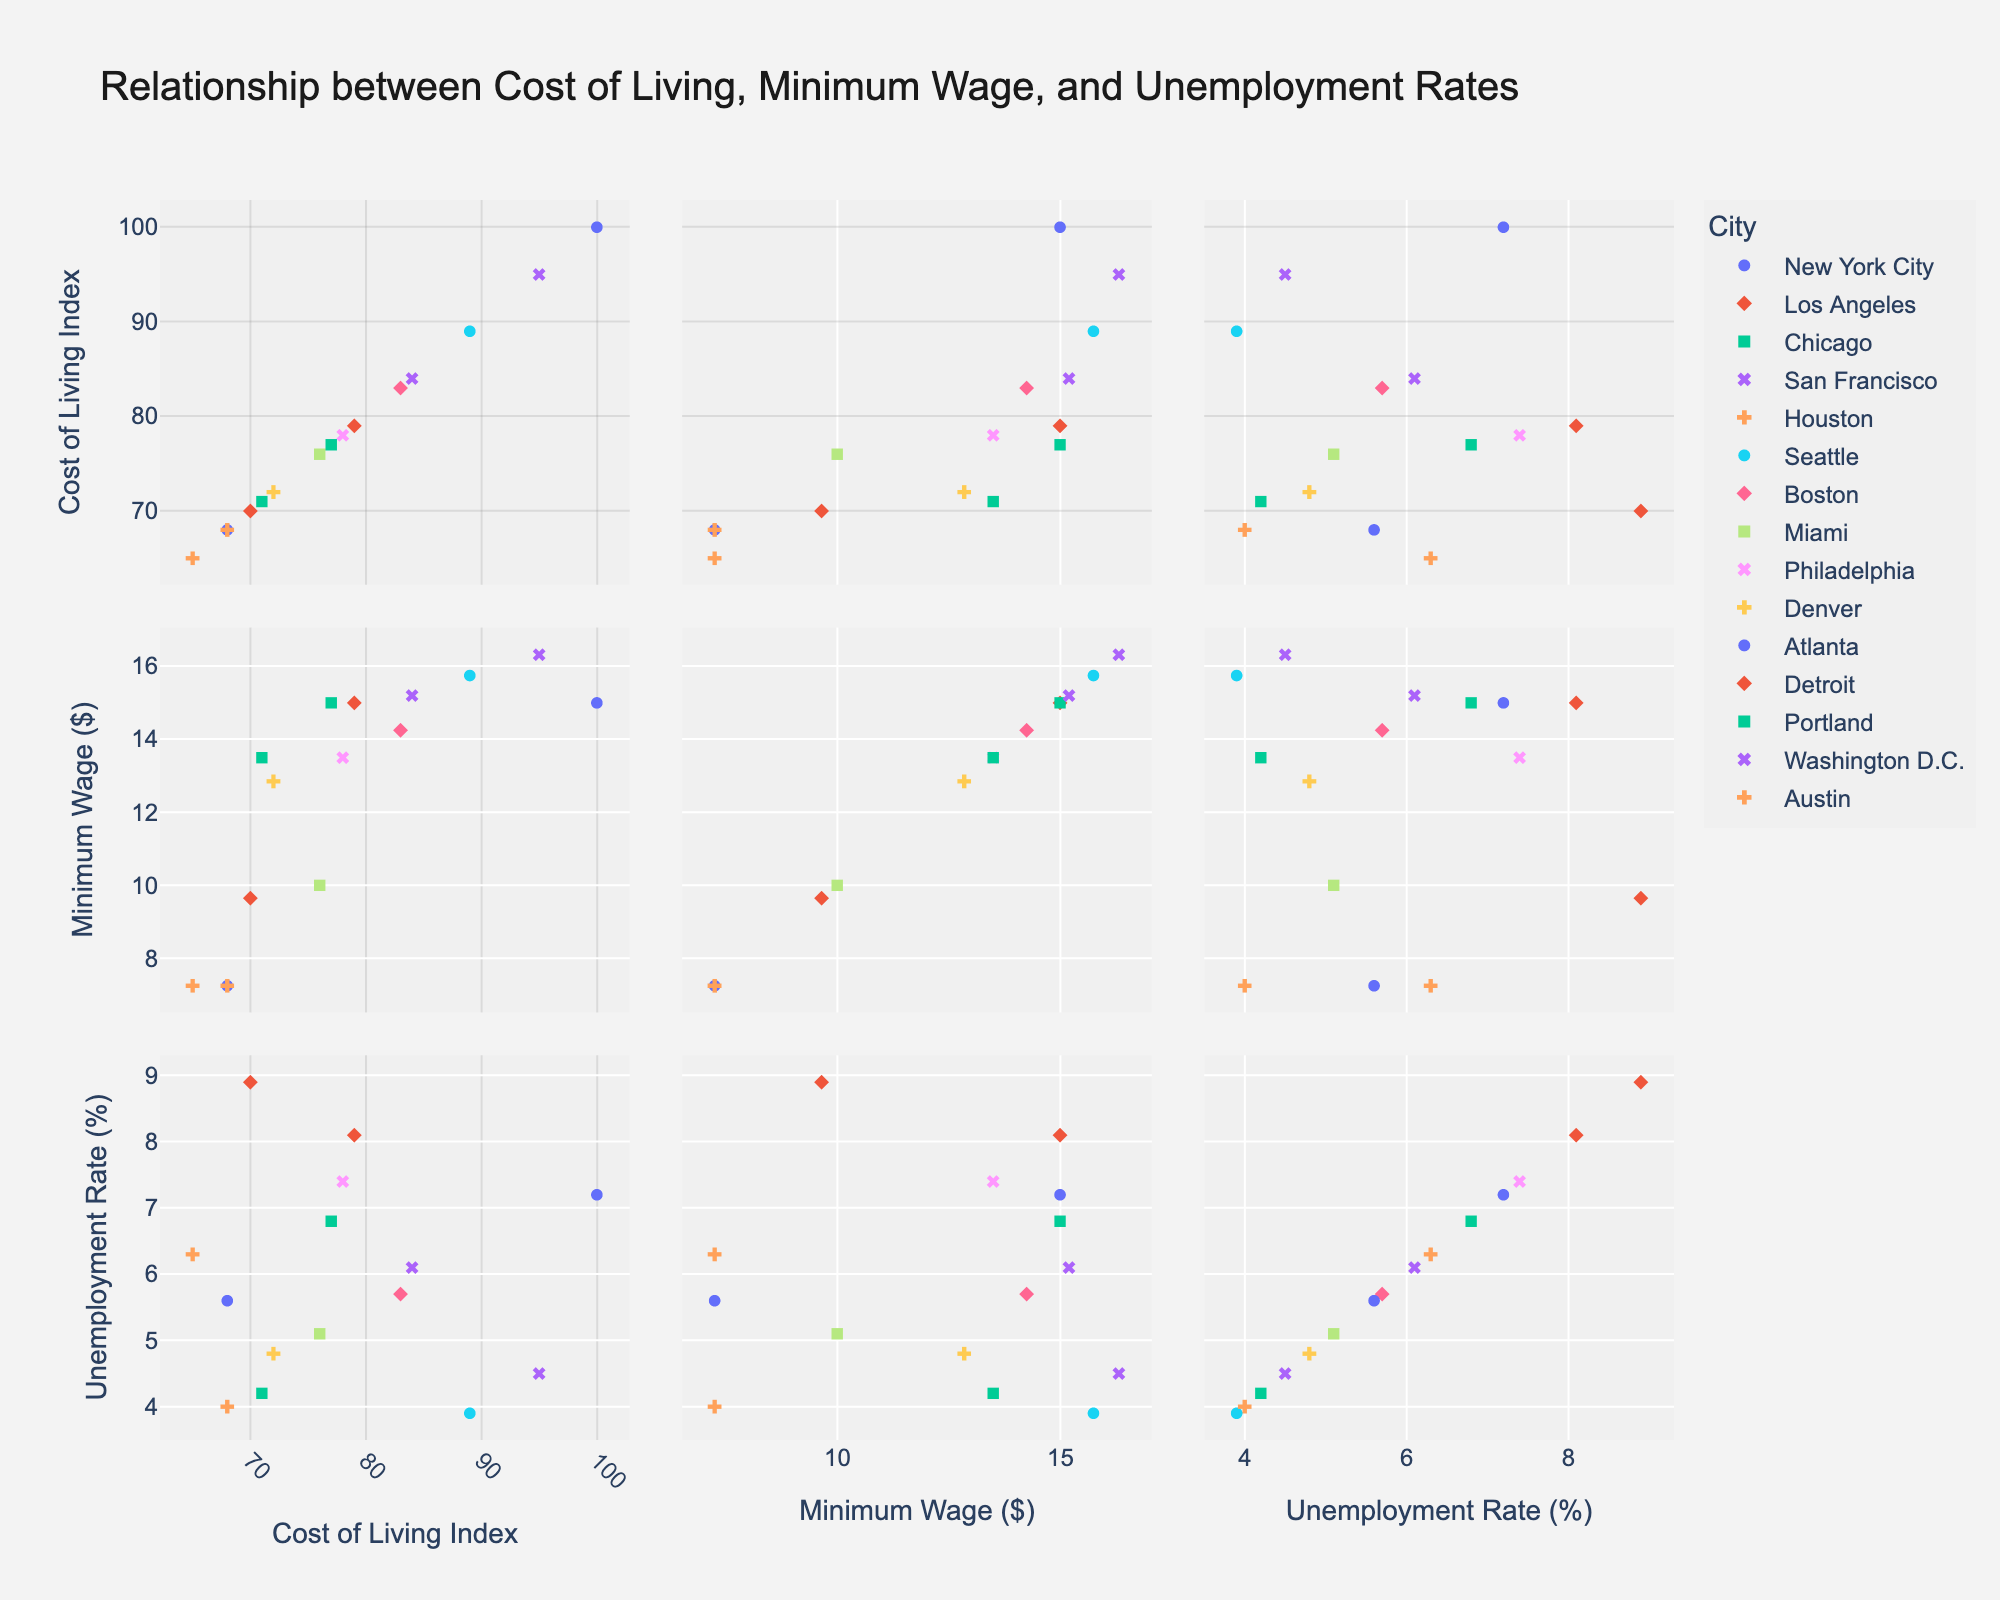What is the title of the plot? The title is usually located at the top of the plot, it provides a brief description of what the plot is about. In this case, it states the relationships being examined.
Answer: Relationship between Cost of Living, Minimum Wage, and Unemployment Rates What's the range of the Cost of Living Index in the plot? By observing the x-axis related to the Cost of Living Index in the scatterplot matrix, you can see the minimum and maximum values.
Answer: 65 to 100 Which city has the highest Cost of Living Index and what is its Minimum Wage? Locate the point furthest to the right on the Cost of Living Index axis and see its corresponding Minimum Wage value.
Answer: New York City, $15.00 What is the relationship between Minimum Wage and Unemployment Rate in Seattle? Find Seattle in the plot and check the intersection points related to Minimum Wage and Unemployment Rate.
Answer: Minimum Wage: $15.75, Unemployment Rate: 3.9% Which city has the highest Unemployment Rate, and what is its Cost of Living Index? Locate the point highest on the Unemployment Rate axis and see its corresponding Cost of Living Index value.
Answer: Detroit, 70 Compare the Minimum Wage of San Francisco and Houston. Which is higher, and by how much? Find both San Francisco and Houston in the plot, observe the Minimum Wage for each city, and then calculate the difference.
Answer: San Francisco’s Minimum Wage is higher by $9.07 What is the average Minimum Wage across all cities shown in the plot? Add up all the Minimum Wage values and divide by the number of cities (15 in this case) to get the average.
Answer: $12.78 Which city with a Minimum Wage equal to or greater than $15.00 has the lowest Unemployment Rate? Identify cities with Minimum Wage equal to or greater than $15 and compare their Unemployment Rates to find the lowest one.
Answer: Seattle How does the Cost of Living Index correlate with the Unemployment Rate in this plot? Examine the scatterplots where both Cost of Living Index and Unemployment Rate are plotted against each other to determine any visible trend or correlation.
Answer: No clear correlation Which city shows a higher Minimum Wage but a lower Unemployment Rate compared to Philadelphia? Check the Minimum Wage and Unemployment Rate for Philadelphia and search for cities with higher Minimum Wage and lower Unemployment Rate.
Answer: Seattle 